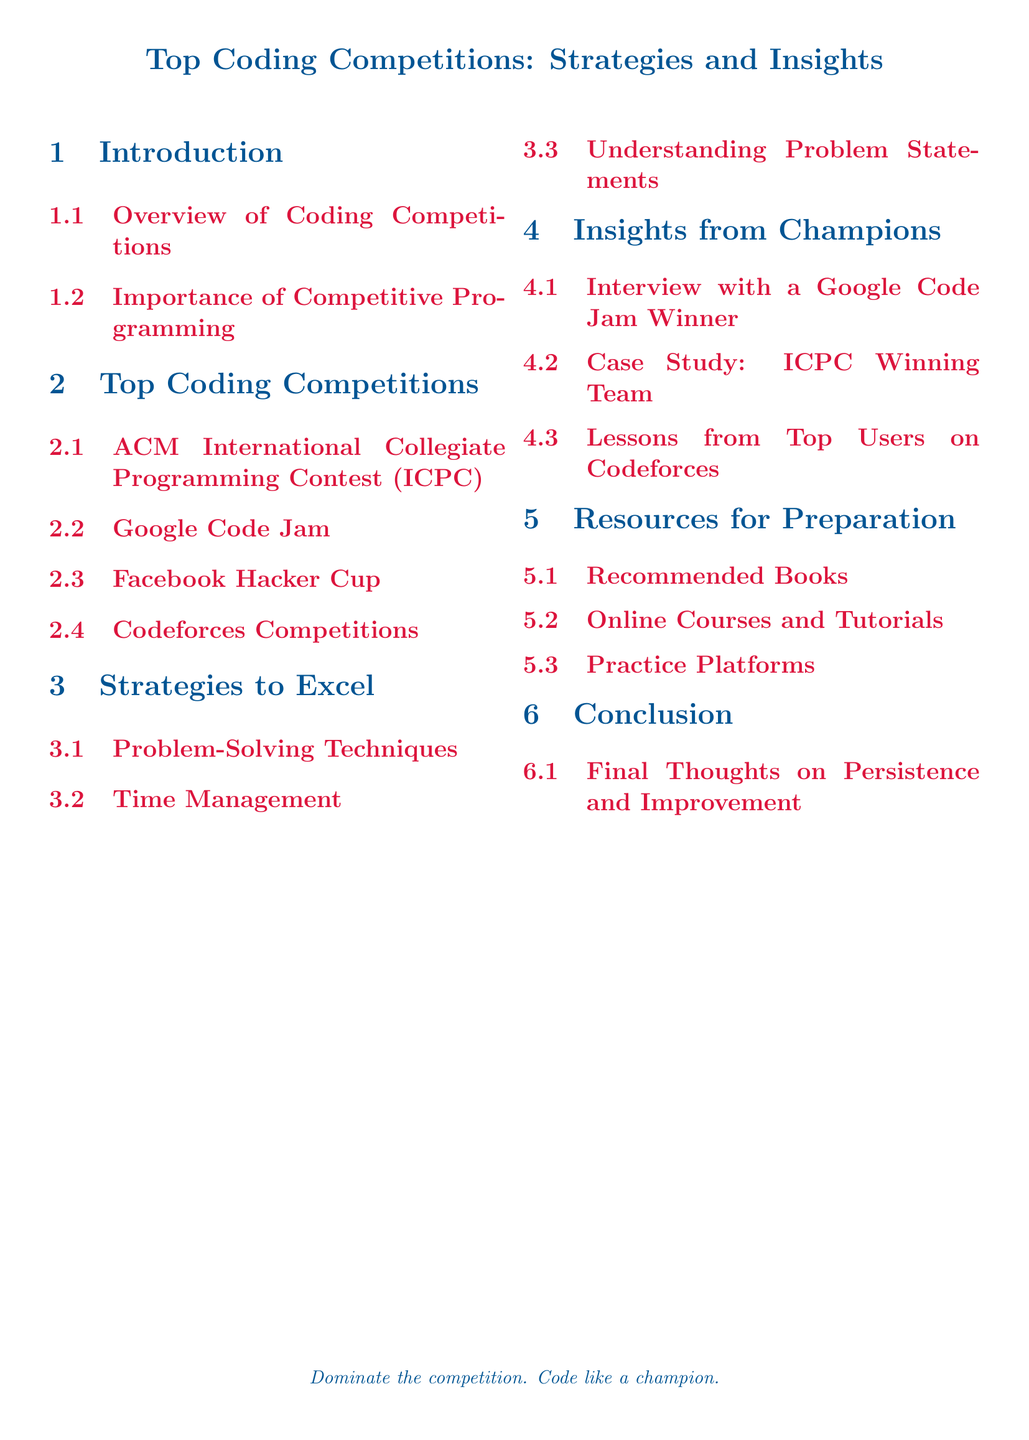What is the title of the document? The title is the main heading of the document, which summarizes its content about coding competitions.
Answer: Top Coding Competitions: Strategies and Insights How many sections are there in the document? The document contains sections which are listed in the table of contents.
Answer: 6 What is the first subsection under the Introduction? The first subsection lists an overview that sets the stage for the rest of the document.
Answer: Overview of Coding Competitions Which competition is listed third in the Top Coding Competitions section? The order of competitions is critical for understanding the document.
Answer: Facebook Hacker Cup What is one key strategy outlined in the Strategies to Excel section? The strategies are tactics that participants can use to succeed in competitions.
Answer: Problem-Solving Techniques Who is featured in the Insights from Champions section? This question focuses on the key persons highlighted in this section related to champion insights.
Answer: Google Code Jam Winner What type of resources are recommended for preparation? This question asks about the type of materials available for users to enhance their skills.
Answer: Books What color is used for section titles in the document? The color used for section titles indicates stylization choices made by the author.
Answer: Male blue What does the conclusion emphasize about competing? The conclusion highlights an important theme that ties together the document’s message.
Answer: Persistence and Improvement 